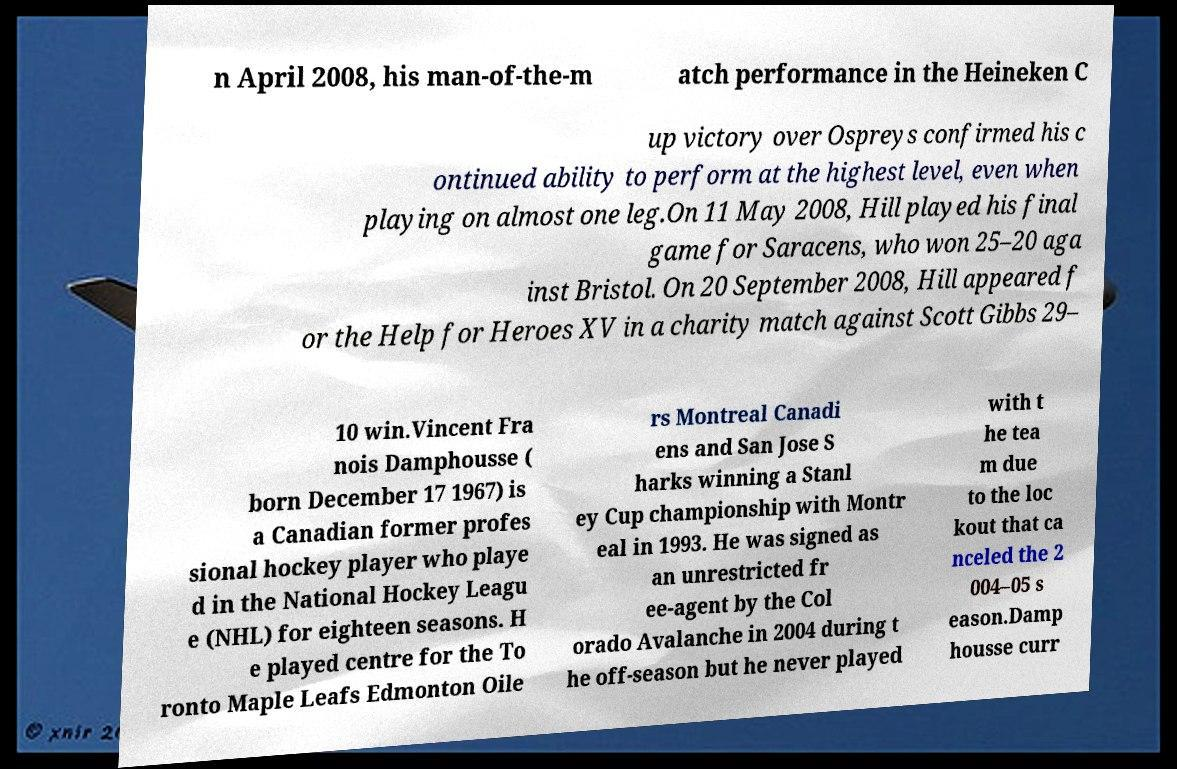Can you accurately transcribe the text from the provided image for me? n April 2008, his man-of-the-m atch performance in the Heineken C up victory over Ospreys confirmed his c ontinued ability to perform at the highest level, even when playing on almost one leg.On 11 May 2008, Hill played his final game for Saracens, who won 25–20 aga inst Bristol. On 20 September 2008, Hill appeared f or the Help for Heroes XV in a charity match against Scott Gibbs 29– 10 win.Vincent Fra nois Damphousse ( born December 17 1967) is a Canadian former profes sional hockey player who playe d in the National Hockey Leagu e (NHL) for eighteen seasons. H e played centre for the To ronto Maple Leafs Edmonton Oile rs Montreal Canadi ens and San Jose S harks winning a Stanl ey Cup championship with Montr eal in 1993. He was signed as an unrestricted fr ee-agent by the Col orado Avalanche in 2004 during t he off-season but he never played with t he tea m due to the loc kout that ca nceled the 2 004–05 s eason.Damp housse curr 